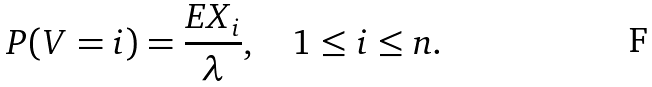Convert formula to latex. <formula><loc_0><loc_0><loc_500><loc_500>P ( V = i ) = \frac { E X _ { i } } { \lambda } , \quad 1 \leq i \leq n .</formula> 